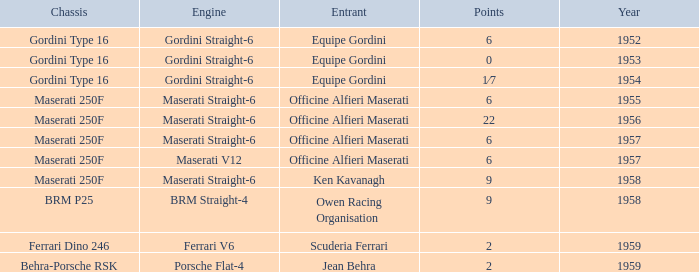What year engine does a ferrari v6 have? 1959.0. 